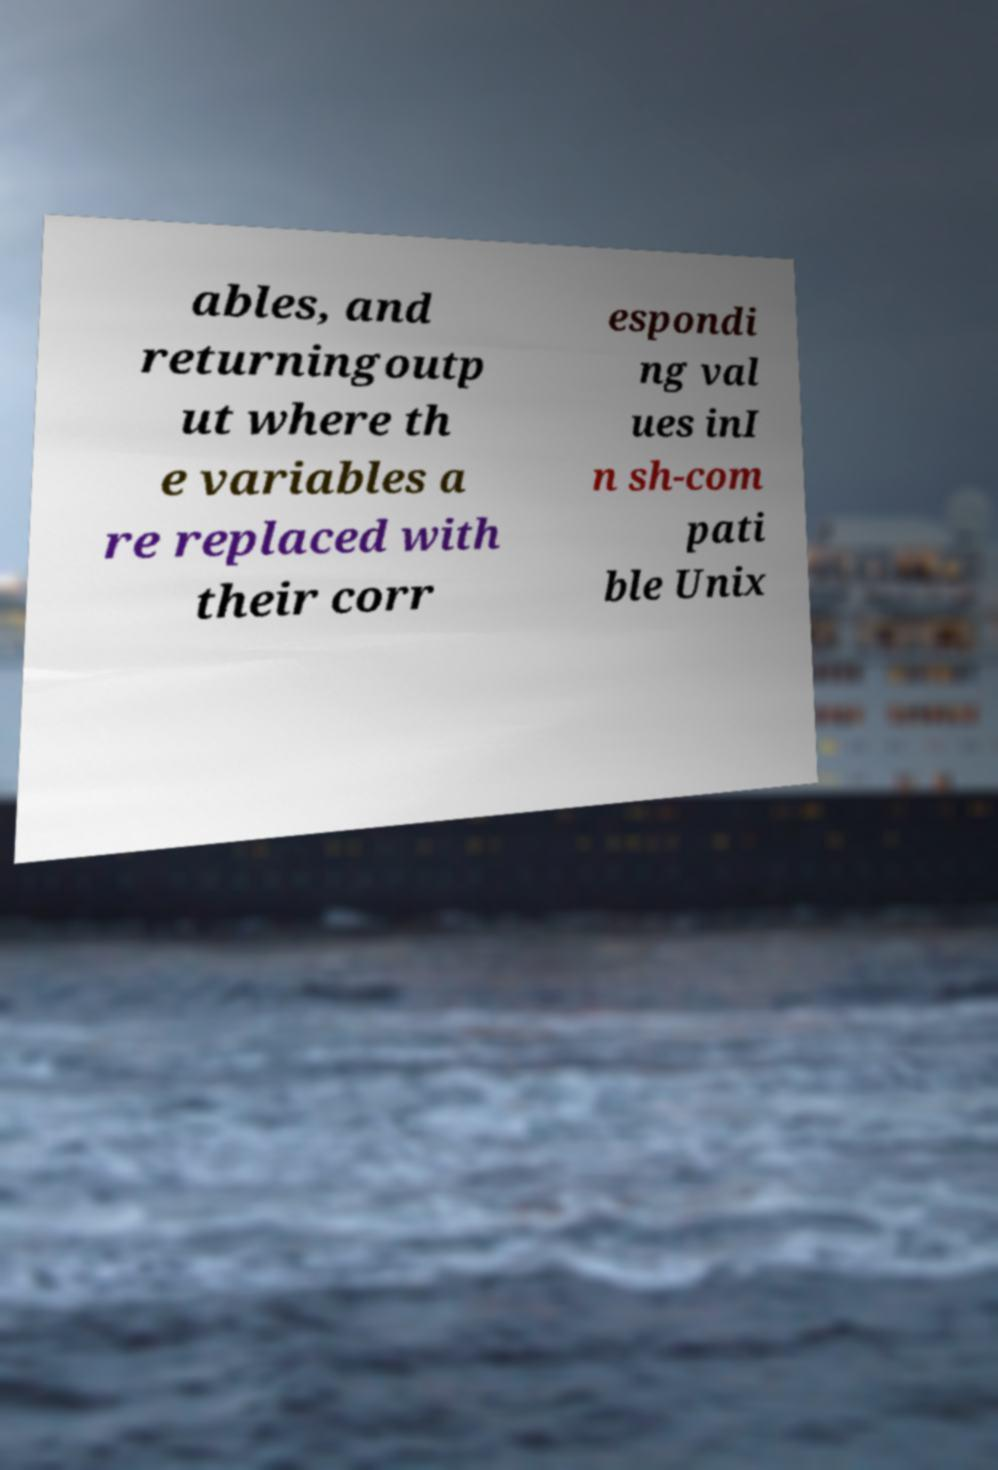There's text embedded in this image that I need extracted. Can you transcribe it verbatim? ables, and returningoutp ut where th e variables a re replaced with their corr espondi ng val ues inI n sh-com pati ble Unix 